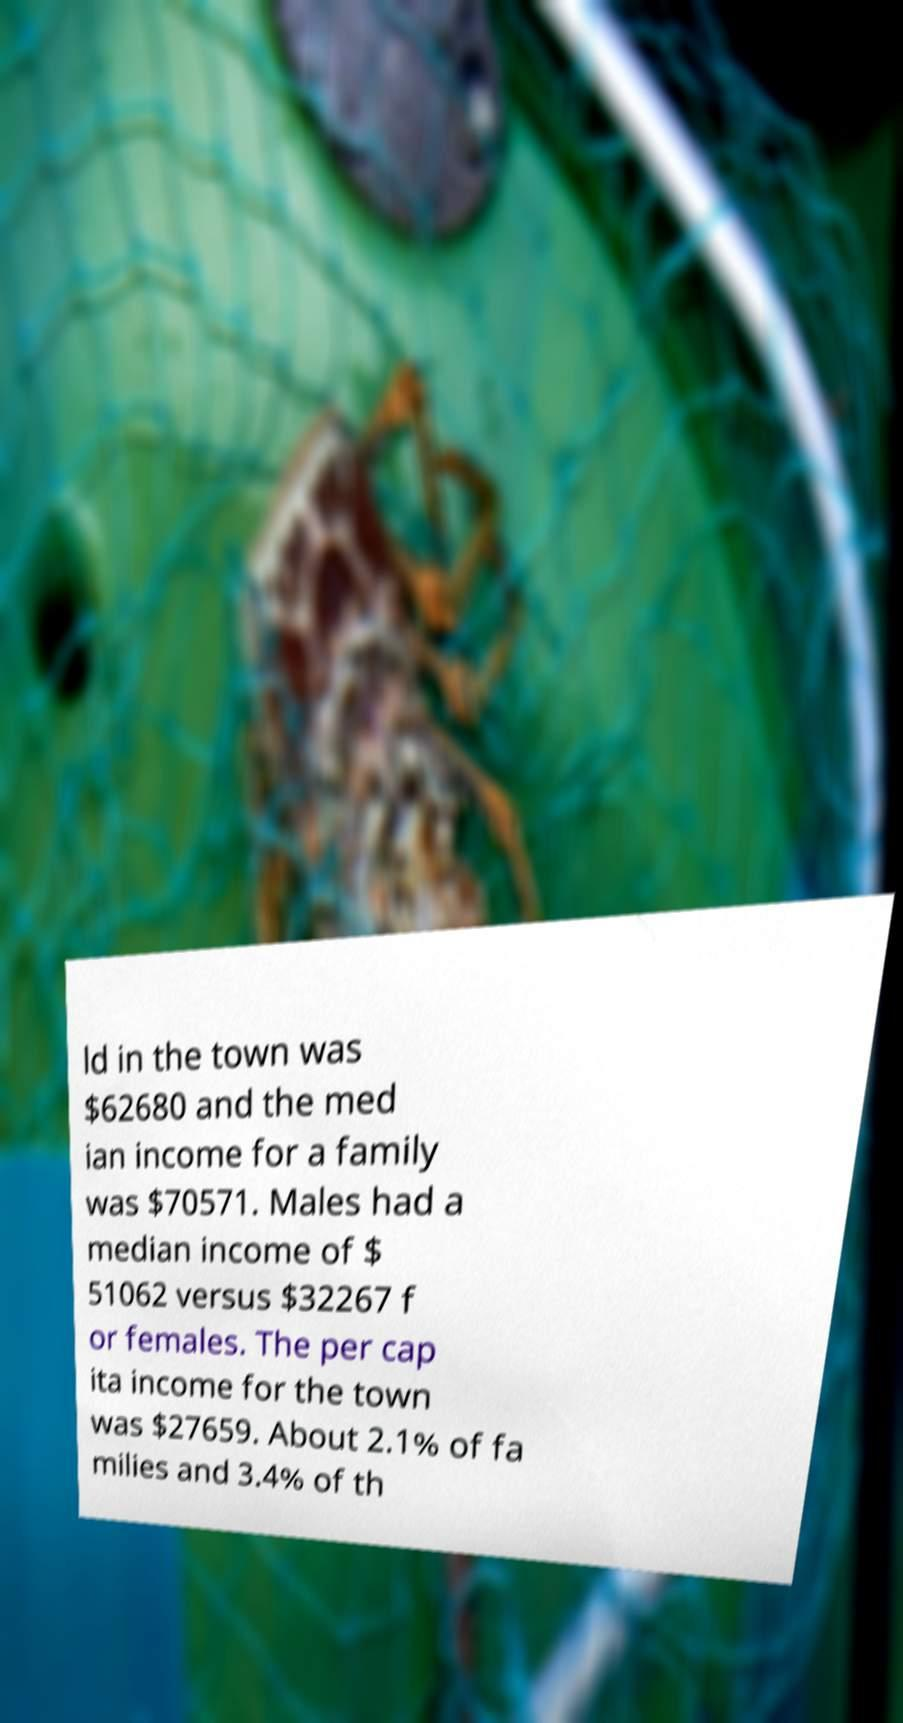What messages or text are displayed in this image? I need them in a readable, typed format. ld in the town was $62680 and the med ian income for a family was $70571. Males had a median income of $ 51062 versus $32267 f or females. The per cap ita income for the town was $27659. About 2.1% of fa milies and 3.4% of th 